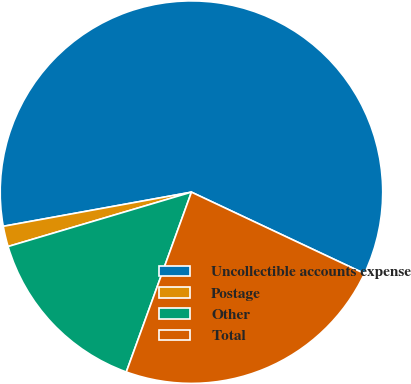<chart> <loc_0><loc_0><loc_500><loc_500><pie_chart><fcel>Uncollectible accounts expense<fcel>Postage<fcel>Other<fcel>Total<nl><fcel>59.86%<fcel>1.73%<fcel>14.88%<fcel>23.53%<nl></chart> 